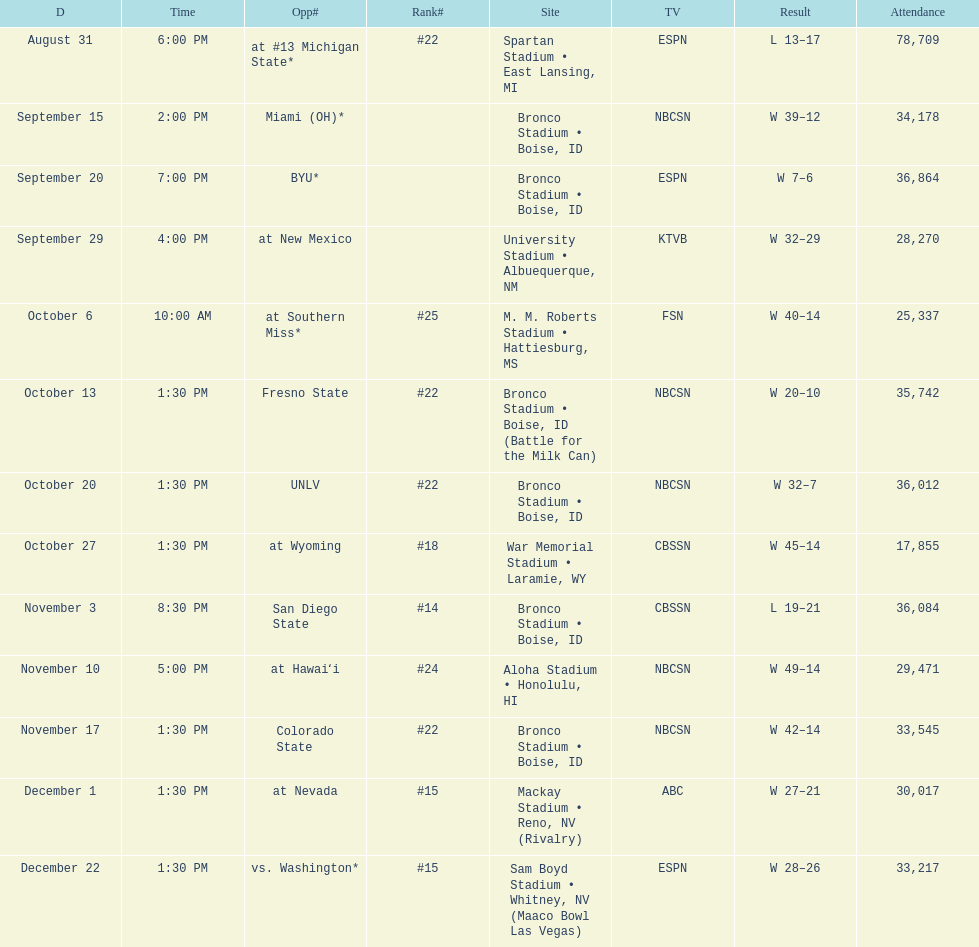Number of points scored by miami (oh) against the broncos. 12. 